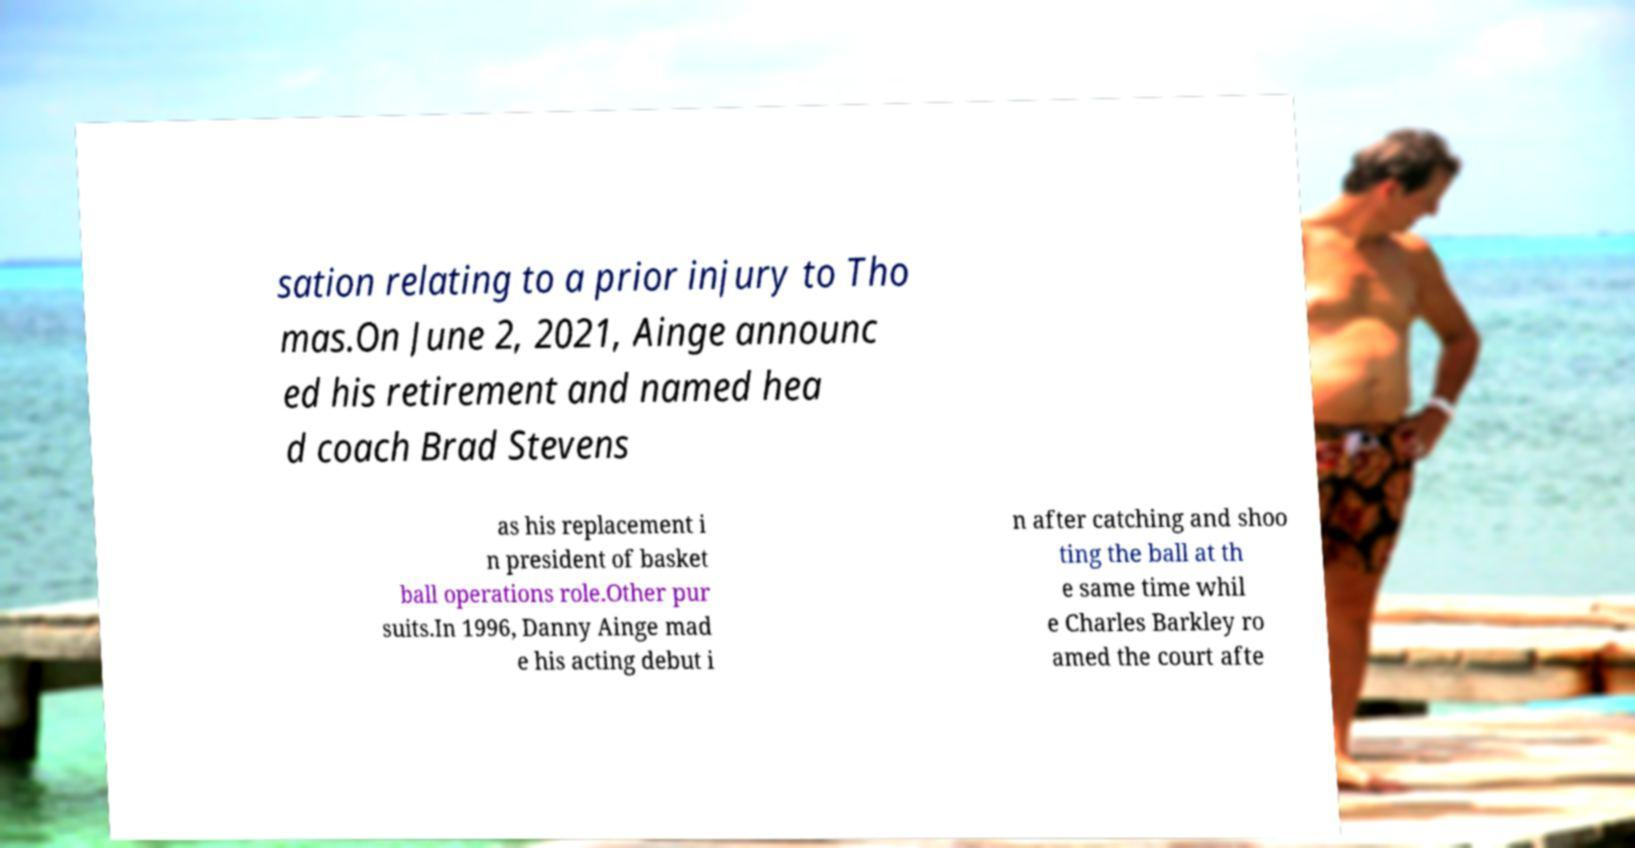What messages or text are displayed in this image? I need them in a readable, typed format. sation relating to a prior injury to Tho mas.On June 2, 2021, Ainge announc ed his retirement and named hea d coach Brad Stevens as his replacement i n president of basket ball operations role.Other pur suits.In 1996, Danny Ainge mad e his acting debut i n after catching and shoo ting the ball at th e same time whil e Charles Barkley ro amed the court afte 